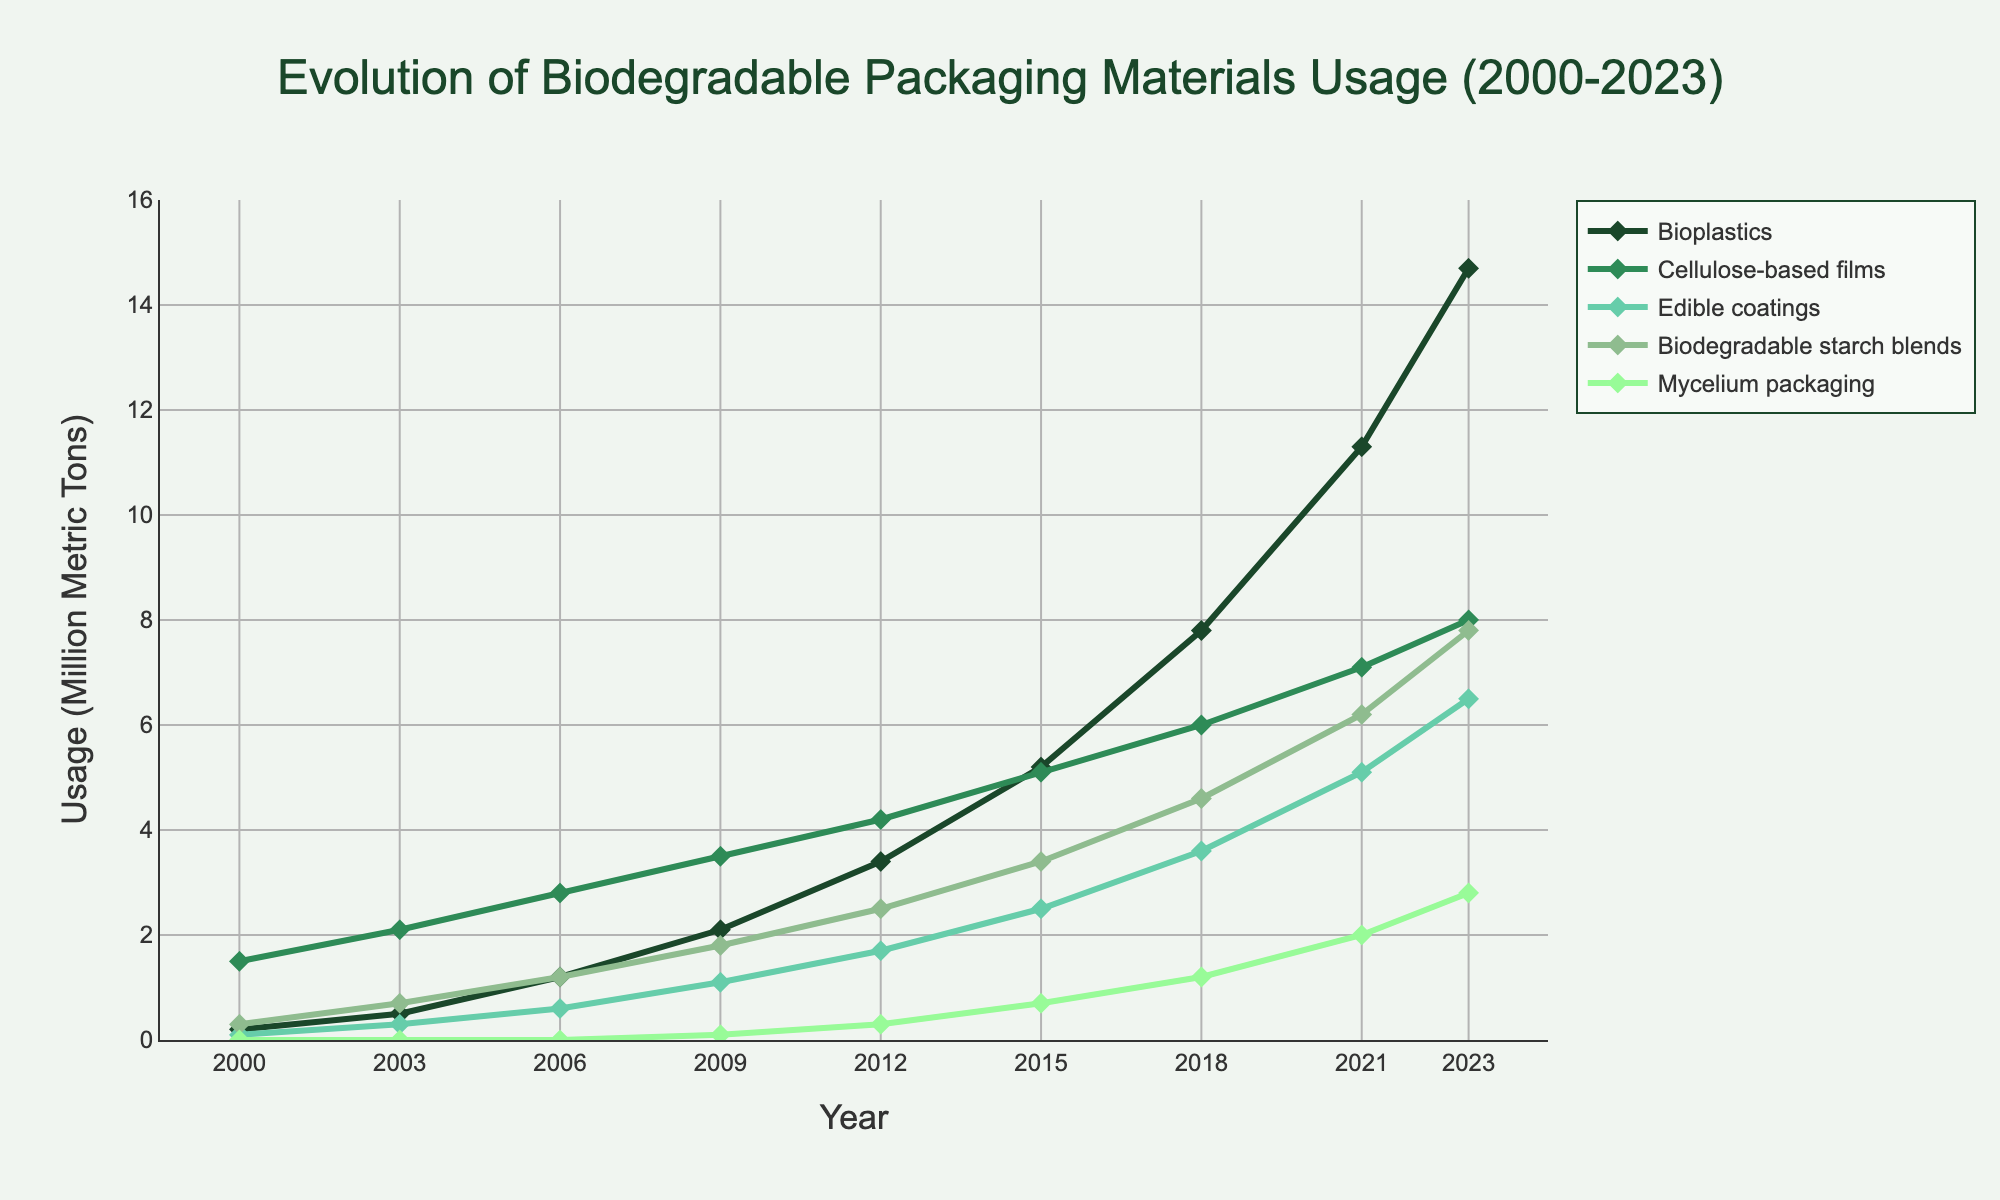What material saw the greatest increase in usage from 2000 to 2023? To determine which material saw the greatest increase, subtract the 2000 value from the 2023 value for each material. Bioplastics: 14.7 - 0.2 = 14.5, Cellulose-based films: 8.0 - 1.5 = 6.5, Edible coatings: 6.5 - 0.1 = 6.4, Biodegradable starch blends: 7.8 - 0.3 = 7.5, Mycelium packaging: 2.8 - 0 = 2.8. Bioplastics have the greatest increase of 14.5.
Answer: Bioplastics Which two materials had the closest usage values in 2023? Compare the values for each pair of materials in 2023. Bioplastics (14.7) and Cellulose-based films (8.0) have a difference of 14.7 - 8.0 = 6.7. Cellulose-based films (8.0) and Edible coatings (6.5) have a difference of 8.0 - 6.5 = 1.5. Edible coatings (6.5) and Biodegradable starch blends (7.8) have a difference of 7.8 - 6.5 = 1.3. The closest values are for Edible coatings and Biodegradable starch blends.
Answer: Edible coatings and Biodegradable starch blends What is the mean usage of Cellulose-based films from 2000 to 2023? Sum the usage values for Cellulose-based films over the years: 1.5 + 2.1 + 2.8 + 3.5 + 4.2 + 5.1 + 6.0 + 7.1 + 8.0 = 40.3. There are 9 years of data. The mean usage is 40.3 / 9 = 4.48.
Answer: 4.48 In which year did Edible coatings see the largest increase from the previous data point? Calculate the differences between consecutive years for Edible coatings: 2003-2000: 0.3 - 0.1 = 0.2, 2006-2003: 0.6 - 0.3 = 0.3, 2009-2006: 1.1 - 0.6 = 0.5, 2012-2009: 1.7 - 1.1 = 0.6, 2015-2012: 2.5 - 1.7 = 0.8, 2018-2015: 3.6 - 2.5 = 1.1, 2021-2018: 5.1 - 3.6 = 1.5, 2023-2021: 6.5 - 5.1 = 1.4. The largest increase is 1.5 from 2018 to 2021.
Answer: 2021 How did the growth trend of Mycelium packaging align with trends in other materials? Mycelium packaging started in 2009 at 0.1 and grew to 2.8 in 2023. It shows consistent growth but on a much smaller scale compared to Bioplastics and other materials, indicating it is a newer innovation with growing acceptance. Bioplastics and Cellulose-based films show stronger and more long-term trends.
Answer: Smaller scale, newer innovation 